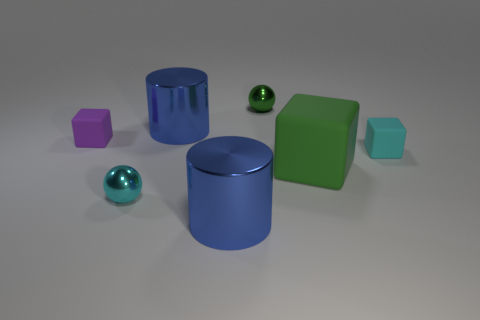Is the number of purple rubber cubes left of the small cyan rubber block the same as the number of tiny shiny balls that are in front of the cyan metal object?
Give a very brief answer. No. Are any big cyan things visible?
Offer a terse response. No. What is the size of the blue shiny cylinder that is behind the metal sphere on the left side of the metal object in front of the cyan ball?
Provide a succinct answer. Large. There is a green metal object that is the same size as the cyan rubber object; what shape is it?
Offer a very short reply. Sphere. Is there anything else that is the same material as the small purple block?
Your answer should be compact. Yes. What number of objects are either small spheres that are in front of the small green metal ball or green rubber cubes?
Offer a terse response. 2. There is a tiny matte object that is on the right side of the tiny shiny sphere that is to the left of the small green sphere; are there any big blue cylinders right of it?
Give a very brief answer. No. What number of big yellow matte cylinders are there?
Provide a succinct answer. 0. What number of objects are large blue metal cylinders that are behind the cyan metal sphere or things that are in front of the tiny cyan rubber cube?
Keep it short and to the point. 4. There is a blue cylinder in front of the cyan sphere; does it have the same size as the tiny cyan metal thing?
Keep it short and to the point. No. 